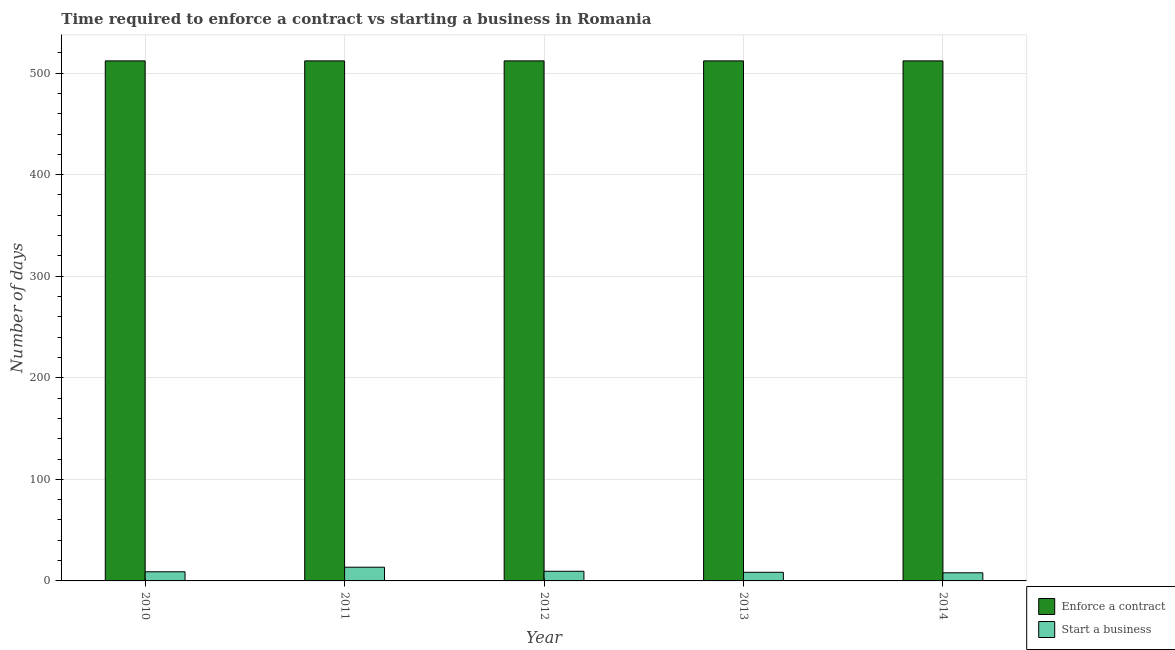How many groups of bars are there?
Ensure brevity in your answer.  5. How many bars are there on the 1st tick from the left?
Provide a short and direct response. 2. What is the label of the 3rd group of bars from the left?
Provide a short and direct response. 2012. What is the number of days to enforece a contract in 2011?
Ensure brevity in your answer.  512. Across all years, what is the maximum number of days to enforece a contract?
Your answer should be compact. 512. Across all years, what is the minimum number of days to start a business?
Offer a very short reply. 8. In which year was the number of days to enforece a contract maximum?
Provide a succinct answer. 2010. What is the total number of days to start a business in the graph?
Your response must be concise. 48.5. What is the difference between the number of days to enforece a contract in 2011 and that in 2013?
Keep it short and to the point. 0. In how many years, is the number of days to enforece a contract greater than 140 days?
Your answer should be very brief. 5. What is the difference between the highest and the second highest number of days to enforece a contract?
Offer a terse response. 0. What is the difference between the highest and the lowest number of days to start a business?
Ensure brevity in your answer.  5.5. In how many years, is the number of days to enforece a contract greater than the average number of days to enforece a contract taken over all years?
Offer a terse response. 0. What does the 1st bar from the left in 2014 represents?
Your response must be concise. Enforce a contract. What does the 1st bar from the right in 2013 represents?
Your response must be concise. Start a business. How many bars are there?
Provide a short and direct response. 10. Does the graph contain any zero values?
Provide a short and direct response. No. How many legend labels are there?
Ensure brevity in your answer.  2. How are the legend labels stacked?
Your response must be concise. Vertical. What is the title of the graph?
Offer a terse response. Time required to enforce a contract vs starting a business in Romania. What is the label or title of the X-axis?
Your answer should be compact. Year. What is the label or title of the Y-axis?
Ensure brevity in your answer.  Number of days. What is the Number of days in Enforce a contract in 2010?
Keep it short and to the point. 512. What is the Number of days of Start a business in 2010?
Your answer should be very brief. 9. What is the Number of days in Enforce a contract in 2011?
Keep it short and to the point. 512. What is the Number of days in Enforce a contract in 2012?
Provide a short and direct response. 512. What is the Number of days in Start a business in 2012?
Offer a terse response. 9.5. What is the Number of days in Enforce a contract in 2013?
Give a very brief answer. 512. What is the Number of days in Start a business in 2013?
Keep it short and to the point. 8.5. What is the Number of days in Enforce a contract in 2014?
Your answer should be very brief. 512. Across all years, what is the maximum Number of days in Enforce a contract?
Provide a short and direct response. 512. Across all years, what is the maximum Number of days of Start a business?
Make the answer very short. 13.5. Across all years, what is the minimum Number of days in Enforce a contract?
Provide a short and direct response. 512. What is the total Number of days in Enforce a contract in the graph?
Offer a very short reply. 2560. What is the total Number of days of Start a business in the graph?
Offer a very short reply. 48.5. What is the difference between the Number of days of Start a business in 2010 and that in 2011?
Provide a succinct answer. -4.5. What is the difference between the Number of days of Enforce a contract in 2010 and that in 2012?
Offer a very short reply. 0. What is the difference between the Number of days in Enforce a contract in 2010 and that in 2013?
Provide a short and direct response. 0. What is the difference between the Number of days of Start a business in 2010 and that in 2014?
Offer a terse response. 1. What is the difference between the Number of days of Enforce a contract in 2011 and that in 2012?
Your answer should be very brief. 0. What is the difference between the Number of days in Start a business in 2011 and that in 2012?
Keep it short and to the point. 4. What is the difference between the Number of days of Enforce a contract in 2011 and that in 2013?
Your response must be concise. 0. What is the difference between the Number of days in Start a business in 2011 and that in 2013?
Give a very brief answer. 5. What is the difference between the Number of days of Start a business in 2011 and that in 2014?
Offer a very short reply. 5.5. What is the difference between the Number of days of Enforce a contract in 2012 and that in 2013?
Your answer should be compact. 0. What is the difference between the Number of days of Enforce a contract in 2013 and that in 2014?
Keep it short and to the point. 0. What is the difference between the Number of days of Start a business in 2013 and that in 2014?
Provide a succinct answer. 0.5. What is the difference between the Number of days of Enforce a contract in 2010 and the Number of days of Start a business in 2011?
Provide a succinct answer. 498.5. What is the difference between the Number of days of Enforce a contract in 2010 and the Number of days of Start a business in 2012?
Ensure brevity in your answer.  502.5. What is the difference between the Number of days of Enforce a contract in 2010 and the Number of days of Start a business in 2013?
Make the answer very short. 503.5. What is the difference between the Number of days in Enforce a contract in 2010 and the Number of days in Start a business in 2014?
Make the answer very short. 504. What is the difference between the Number of days of Enforce a contract in 2011 and the Number of days of Start a business in 2012?
Ensure brevity in your answer.  502.5. What is the difference between the Number of days in Enforce a contract in 2011 and the Number of days in Start a business in 2013?
Make the answer very short. 503.5. What is the difference between the Number of days of Enforce a contract in 2011 and the Number of days of Start a business in 2014?
Make the answer very short. 504. What is the difference between the Number of days in Enforce a contract in 2012 and the Number of days in Start a business in 2013?
Keep it short and to the point. 503.5. What is the difference between the Number of days of Enforce a contract in 2012 and the Number of days of Start a business in 2014?
Provide a short and direct response. 504. What is the difference between the Number of days of Enforce a contract in 2013 and the Number of days of Start a business in 2014?
Provide a short and direct response. 504. What is the average Number of days of Enforce a contract per year?
Your response must be concise. 512. In the year 2010, what is the difference between the Number of days in Enforce a contract and Number of days in Start a business?
Keep it short and to the point. 503. In the year 2011, what is the difference between the Number of days of Enforce a contract and Number of days of Start a business?
Make the answer very short. 498.5. In the year 2012, what is the difference between the Number of days of Enforce a contract and Number of days of Start a business?
Your response must be concise. 502.5. In the year 2013, what is the difference between the Number of days of Enforce a contract and Number of days of Start a business?
Give a very brief answer. 503.5. In the year 2014, what is the difference between the Number of days of Enforce a contract and Number of days of Start a business?
Your response must be concise. 504. What is the ratio of the Number of days of Enforce a contract in 2010 to that in 2011?
Provide a succinct answer. 1. What is the ratio of the Number of days in Enforce a contract in 2010 to that in 2013?
Offer a terse response. 1. What is the ratio of the Number of days in Start a business in 2010 to that in 2013?
Give a very brief answer. 1.06. What is the ratio of the Number of days of Enforce a contract in 2010 to that in 2014?
Offer a very short reply. 1. What is the ratio of the Number of days in Enforce a contract in 2011 to that in 2012?
Your answer should be compact. 1. What is the ratio of the Number of days of Start a business in 2011 to that in 2012?
Ensure brevity in your answer.  1.42. What is the ratio of the Number of days in Start a business in 2011 to that in 2013?
Keep it short and to the point. 1.59. What is the ratio of the Number of days in Start a business in 2011 to that in 2014?
Give a very brief answer. 1.69. What is the ratio of the Number of days in Start a business in 2012 to that in 2013?
Give a very brief answer. 1.12. What is the ratio of the Number of days in Start a business in 2012 to that in 2014?
Offer a very short reply. 1.19. What is the ratio of the Number of days in Start a business in 2013 to that in 2014?
Offer a terse response. 1.06. What is the difference between the highest and the second highest Number of days in Enforce a contract?
Your response must be concise. 0. What is the difference between the highest and the lowest Number of days in Start a business?
Your answer should be very brief. 5.5. 